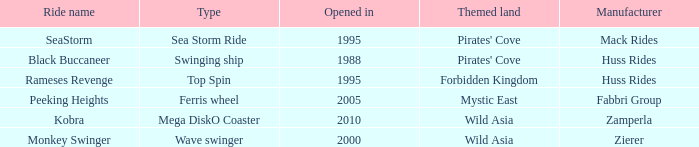What type ride is Wild Asia that opened in 2000? Wave swinger. 